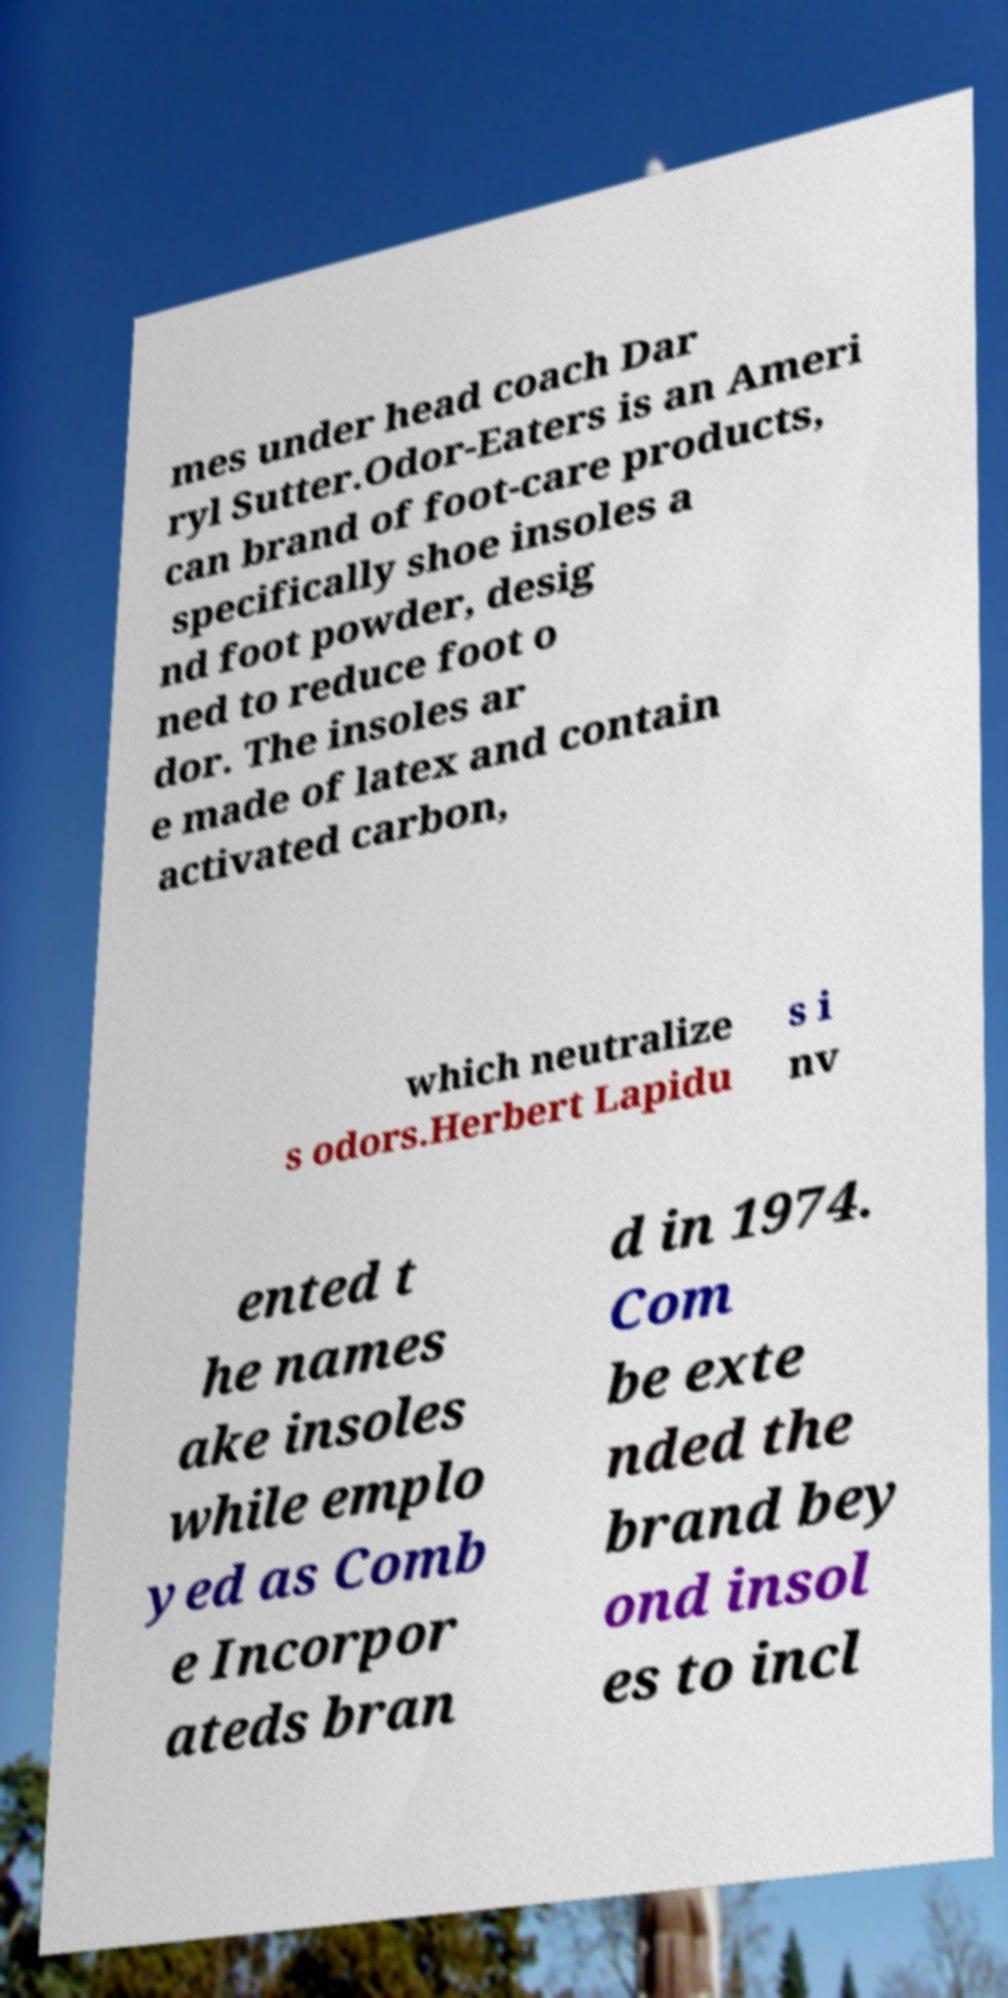Could you extract and type out the text from this image? mes under head coach Dar ryl Sutter.Odor-Eaters is an Ameri can brand of foot-care products, specifically shoe insoles a nd foot powder, desig ned to reduce foot o dor. The insoles ar e made of latex and contain activated carbon, which neutralize s odors.Herbert Lapidu s i nv ented t he names ake insoles while emplo yed as Comb e Incorpor ateds bran d in 1974. Com be exte nded the brand bey ond insol es to incl 